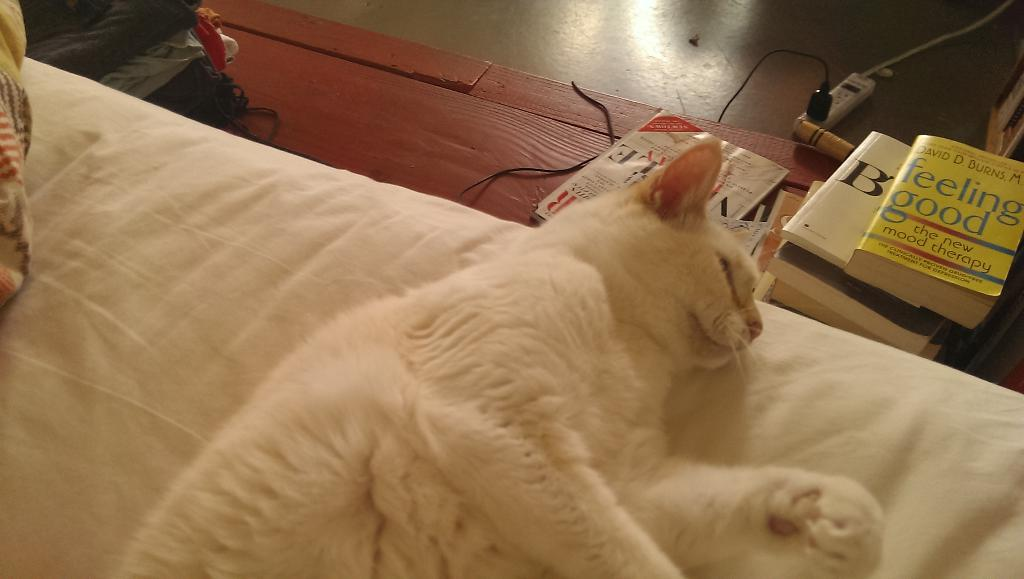What type of animal is on the bed in the image? There is a cat on the bed in the image. What objects can be seen in the image besides the cat? There are books, a cable, and clothes visible in the image. What part of the room can be seen in the image? The floor is visible in the image. What type of train can be seen in the image? There is no train present in the image. What type of polish is being used on the screw in the image? There is no screw or polish present in the image. 